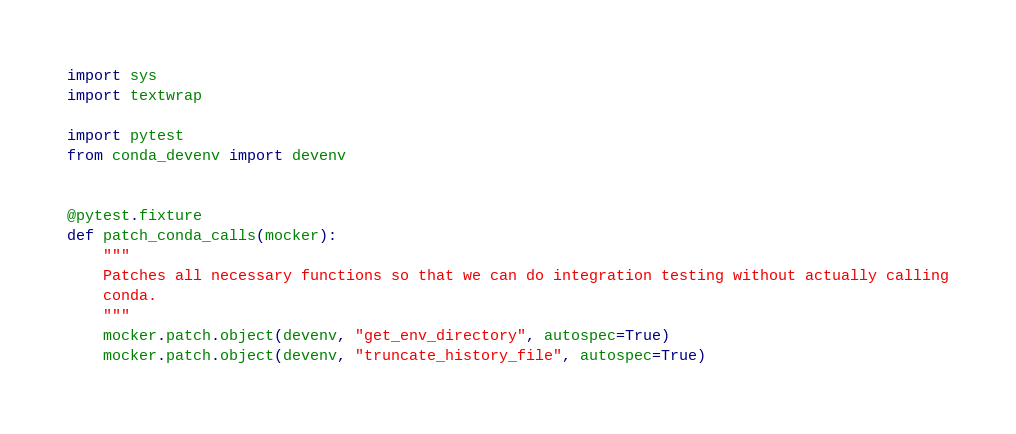<code> <loc_0><loc_0><loc_500><loc_500><_Python_>import sys
import textwrap

import pytest
from conda_devenv import devenv


@pytest.fixture
def patch_conda_calls(mocker):
    """
    Patches all necessary functions so that we can do integration testing without actually calling
    conda.
    """
    mocker.patch.object(devenv, "get_env_directory", autospec=True)
    mocker.patch.object(devenv, "truncate_history_file", autospec=True)</code> 